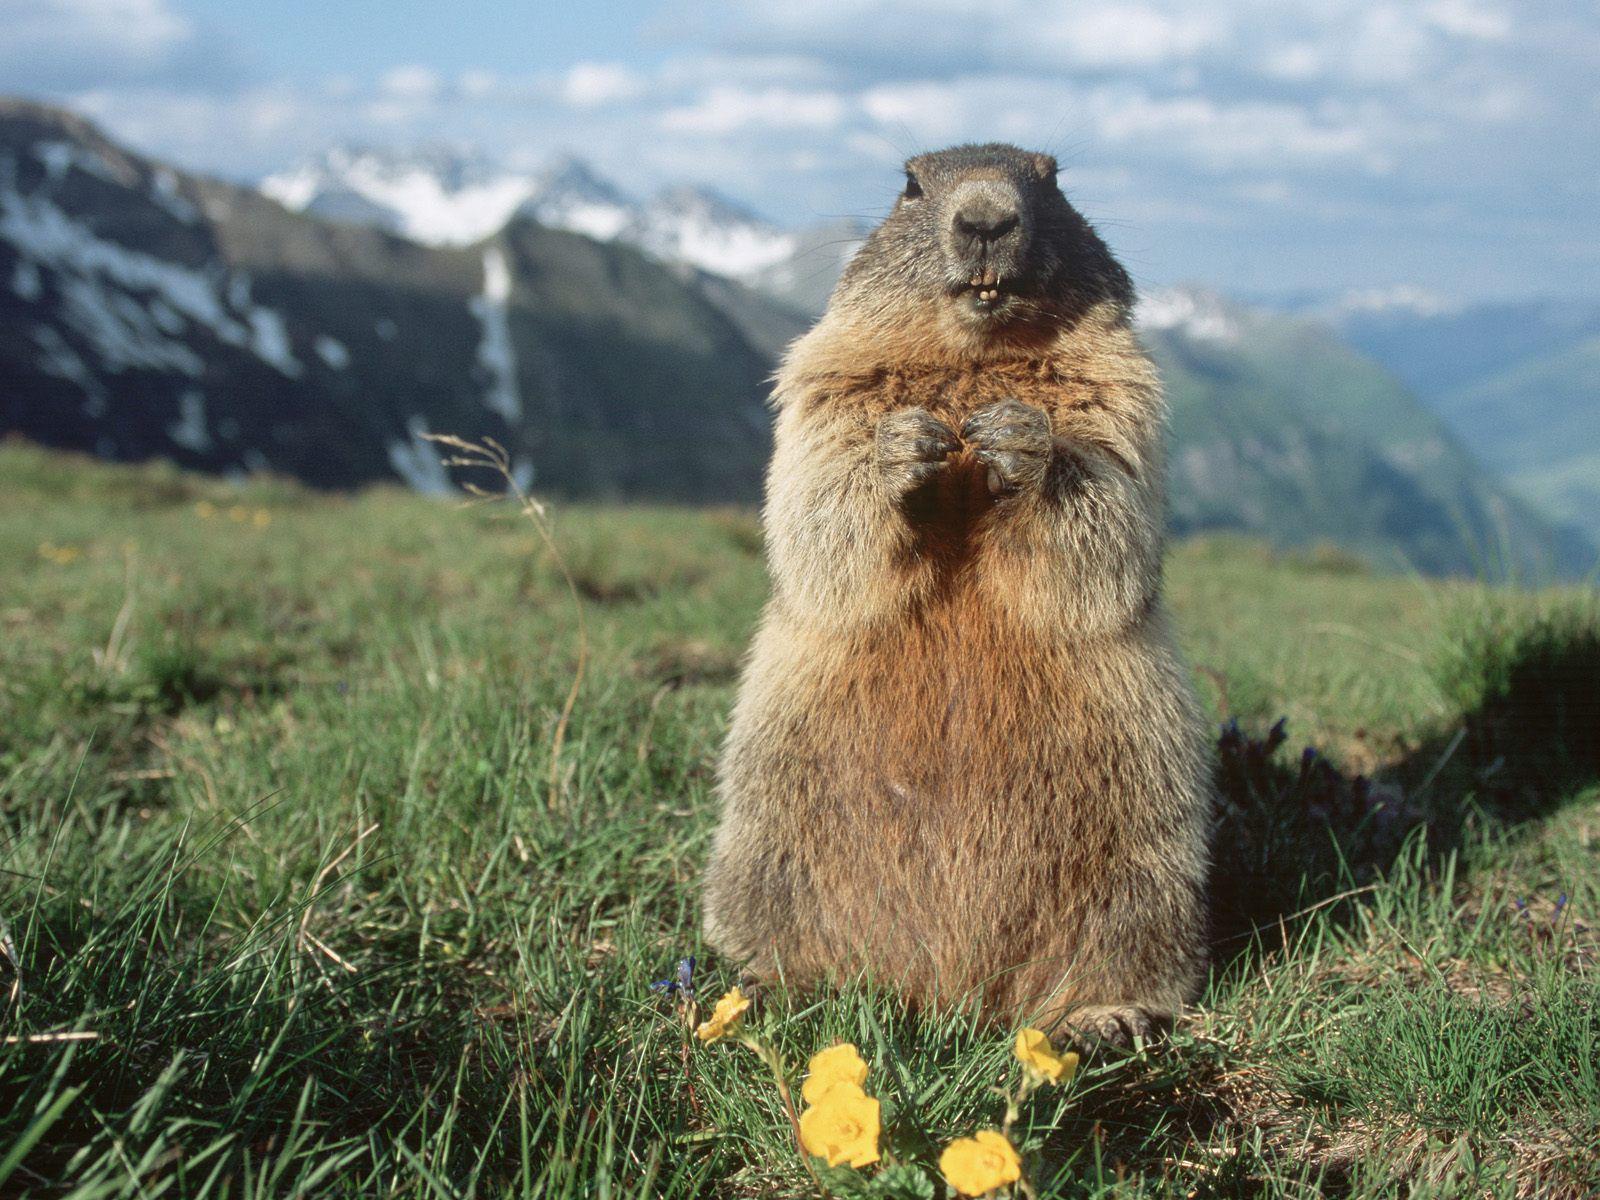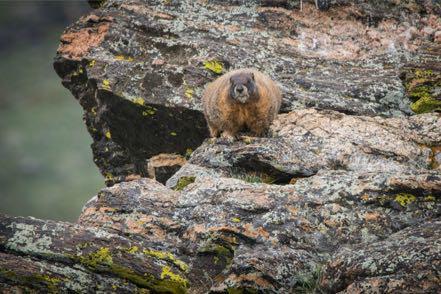The first image is the image on the left, the second image is the image on the right. Evaluate the accuracy of this statement regarding the images: "An image shows a row of four prairie dog type animals, standing upright eating crackers.". Is it true? Answer yes or no. No. 